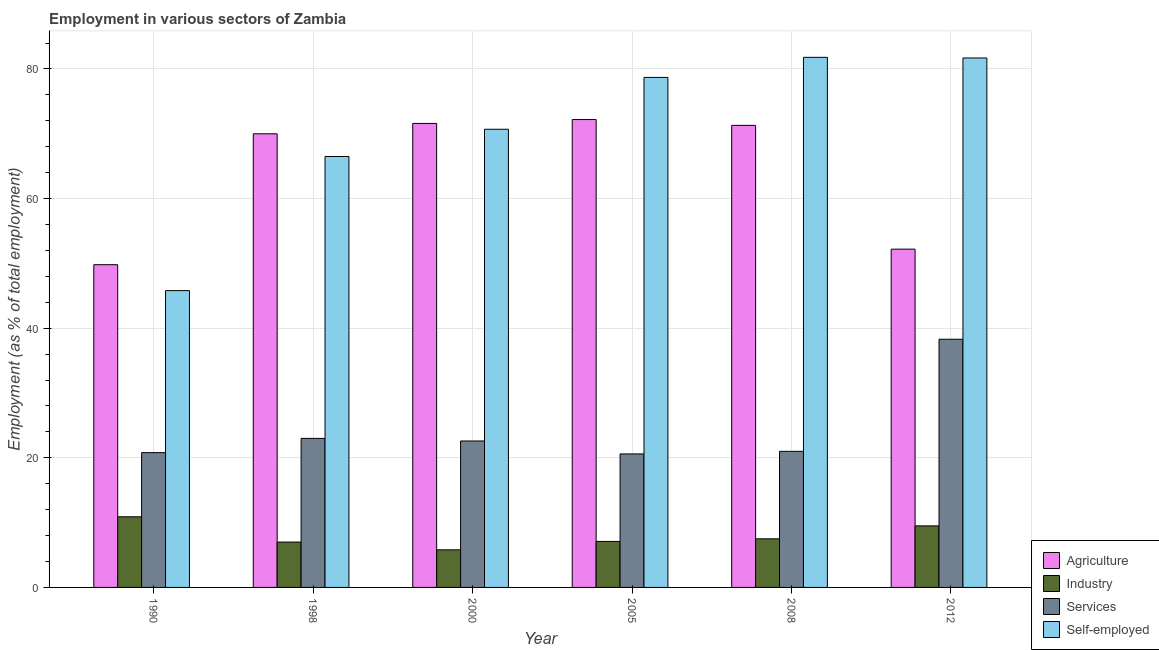How many groups of bars are there?
Make the answer very short. 6. How many bars are there on the 5th tick from the right?
Ensure brevity in your answer.  4. In how many cases, is the number of bars for a given year not equal to the number of legend labels?
Offer a terse response. 0. What is the percentage of self employed workers in 2008?
Give a very brief answer. 81.8. Across all years, what is the maximum percentage of workers in industry?
Your response must be concise. 10.9. Across all years, what is the minimum percentage of workers in services?
Give a very brief answer. 20.6. What is the total percentage of workers in services in the graph?
Your response must be concise. 146.3. What is the difference between the percentage of self employed workers in 1990 and that in 2005?
Provide a succinct answer. -32.9. What is the difference between the percentage of workers in industry in 1990 and the percentage of self employed workers in 2000?
Offer a terse response. 5.1. What is the average percentage of self employed workers per year?
Make the answer very short. 70.87. What is the ratio of the percentage of self employed workers in 1998 to that in 2012?
Keep it short and to the point. 0.81. Is the percentage of workers in agriculture in 2005 less than that in 2012?
Provide a short and direct response. No. What is the difference between the highest and the second highest percentage of workers in agriculture?
Make the answer very short. 0.6. What is the difference between the highest and the lowest percentage of self employed workers?
Give a very brief answer. 36. What does the 3rd bar from the left in 2005 represents?
Offer a very short reply. Services. What does the 1st bar from the right in 2012 represents?
Your response must be concise. Self-employed. Is it the case that in every year, the sum of the percentage of workers in agriculture and percentage of workers in industry is greater than the percentage of workers in services?
Keep it short and to the point. Yes. Are the values on the major ticks of Y-axis written in scientific E-notation?
Provide a short and direct response. No. Does the graph contain any zero values?
Offer a very short reply. No. Does the graph contain grids?
Keep it short and to the point. Yes. Where does the legend appear in the graph?
Offer a very short reply. Bottom right. How many legend labels are there?
Give a very brief answer. 4. What is the title of the graph?
Your answer should be compact. Employment in various sectors of Zambia. Does "Energy" appear as one of the legend labels in the graph?
Ensure brevity in your answer.  No. What is the label or title of the Y-axis?
Give a very brief answer. Employment (as % of total employment). What is the Employment (as % of total employment) of Agriculture in 1990?
Your answer should be very brief. 49.8. What is the Employment (as % of total employment) in Industry in 1990?
Offer a very short reply. 10.9. What is the Employment (as % of total employment) of Services in 1990?
Ensure brevity in your answer.  20.8. What is the Employment (as % of total employment) of Self-employed in 1990?
Your response must be concise. 45.8. What is the Employment (as % of total employment) in Agriculture in 1998?
Provide a short and direct response. 70. What is the Employment (as % of total employment) in Industry in 1998?
Provide a short and direct response. 7. What is the Employment (as % of total employment) of Services in 1998?
Your response must be concise. 23. What is the Employment (as % of total employment) of Self-employed in 1998?
Provide a succinct answer. 66.5. What is the Employment (as % of total employment) of Agriculture in 2000?
Provide a succinct answer. 71.6. What is the Employment (as % of total employment) in Industry in 2000?
Make the answer very short. 5.8. What is the Employment (as % of total employment) of Services in 2000?
Your answer should be compact. 22.6. What is the Employment (as % of total employment) in Self-employed in 2000?
Your answer should be very brief. 70.7. What is the Employment (as % of total employment) in Agriculture in 2005?
Ensure brevity in your answer.  72.2. What is the Employment (as % of total employment) in Industry in 2005?
Keep it short and to the point. 7.1. What is the Employment (as % of total employment) in Services in 2005?
Give a very brief answer. 20.6. What is the Employment (as % of total employment) in Self-employed in 2005?
Your response must be concise. 78.7. What is the Employment (as % of total employment) in Agriculture in 2008?
Provide a short and direct response. 71.3. What is the Employment (as % of total employment) of Services in 2008?
Give a very brief answer. 21. What is the Employment (as % of total employment) of Self-employed in 2008?
Offer a very short reply. 81.8. What is the Employment (as % of total employment) of Agriculture in 2012?
Provide a succinct answer. 52.2. What is the Employment (as % of total employment) of Services in 2012?
Offer a very short reply. 38.3. What is the Employment (as % of total employment) in Self-employed in 2012?
Provide a short and direct response. 81.7. Across all years, what is the maximum Employment (as % of total employment) of Agriculture?
Provide a short and direct response. 72.2. Across all years, what is the maximum Employment (as % of total employment) of Industry?
Your response must be concise. 10.9. Across all years, what is the maximum Employment (as % of total employment) of Services?
Provide a short and direct response. 38.3. Across all years, what is the maximum Employment (as % of total employment) of Self-employed?
Offer a terse response. 81.8. Across all years, what is the minimum Employment (as % of total employment) of Agriculture?
Offer a very short reply. 49.8. Across all years, what is the minimum Employment (as % of total employment) in Industry?
Keep it short and to the point. 5.8. Across all years, what is the minimum Employment (as % of total employment) of Services?
Give a very brief answer. 20.6. Across all years, what is the minimum Employment (as % of total employment) of Self-employed?
Keep it short and to the point. 45.8. What is the total Employment (as % of total employment) of Agriculture in the graph?
Offer a very short reply. 387.1. What is the total Employment (as % of total employment) in Industry in the graph?
Give a very brief answer. 47.8. What is the total Employment (as % of total employment) of Services in the graph?
Ensure brevity in your answer.  146.3. What is the total Employment (as % of total employment) in Self-employed in the graph?
Your answer should be very brief. 425.2. What is the difference between the Employment (as % of total employment) in Agriculture in 1990 and that in 1998?
Provide a succinct answer. -20.2. What is the difference between the Employment (as % of total employment) of Industry in 1990 and that in 1998?
Offer a terse response. 3.9. What is the difference between the Employment (as % of total employment) in Services in 1990 and that in 1998?
Provide a short and direct response. -2.2. What is the difference between the Employment (as % of total employment) in Self-employed in 1990 and that in 1998?
Give a very brief answer. -20.7. What is the difference between the Employment (as % of total employment) of Agriculture in 1990 and that in 2000?
Provide a short and direct response. -21.8. What is the difference between the Employment (as % of total employment) of Services in 1990 and that in 2000?
Offer a very short reply. -1.8. What is the difference between the Employment (as % of total employment) in Self-employed in 1990 and that in 2000?
Your answer should be very brief. -24.9. What is the difference between the Employment (as % of total employment) of Agriculture in 1990 and that in 2005?
Keep it short and to the point. -22.4. What is the difference between the Employment (as % of total employment) of Industry in 1990 and that in 2005?
Your response must be concise. 3.8. What is the difference between the Employment (as % of total employment) of Self-employed in 1990 and that in 2005?
Your answer should be compact. -32.9. What is the difference between the Employment (as % of total employment) in Agriculture in 1990 and that in 2008?
Provide a short and direct response. -21.5. What is the difference between the Employment (as % of total employment) of Services in 1990 and that in 2008?
Give a very brief answer. -0.2. What is the difference between the Employment (as % of total employment) of Self-employed in 1990 and that in 2008?
Keep it short and to the point. -36. What is the difference between the Employment (as % of total employment) of Agriculture in 1990 and that in 2012?
Your answer should be compact. -2.4. What is the difference between the Employment (as % of total employment) in Industry in 1990 and that in 2012?
Your answer should be compact. 1.4. What is the difference between the Employment (as % of total employment) in Services in 1990 and that in 2012?
Ensure brevity in your answer.  -17.5. What is the difference between the Employment (as % of total employment) of Self-employed in 1990 and that in 2012?
Ensure brevity in your answer.  -35.9. What is the difference between the Employment (as % of total employment) of Agriculture in 1998 and that in 2005?
Offer a terse response. -2.2. What is the difference between the Employment (as % of total employment) in Agriculture in 1998 and that in 2008?
Make the answer very short. -1.3. What is the difference between the Employment (as % of total employment) in Services in 1998 and that in 2008?
Keep it short and to the point. 2. What is the difference between the Employment (as % of total employment) in Self-employed in 1998 and that in 2008?
Your answer should be very brief. -15.3. What is the difference between the Employment (as % of total employment) in Agriculture in 1998 and that in 2012?
Keep it short and to the point. 17.8. What is the difference between the Employment (as % of total employment) in Services in 1998 and that in 2012?
Provide a succinct answer. -15.3. What is the difference between the Employment (as % of total employment) in Self-employed in 1998 and that in 2012?
Offer a very short reply. -15.2. What is the difference between the Employment (as % of total employment) of Agriculture in 2000 and that in 2005?
Give a very brief answer. -0.6. What is the difference between the Employment (as % of total employment) of Agriculture in 2000 and that in 2008?
Your response must be concise. 0.3. What is the difference between the Employment (as % of total employment) of Industry in 2000 and that in 2008?
Provide a short and direct response. -1.7. What is the difference between the Employment (as % of total employment) of Services in 2000 and that in 2008?
Offer a terse response. 1.6. What is the difference between the Employment (as % of total employment) of Self-employed in 2000 and that in 2008?
Provide a short and direct response. -11.1. What is the difference between the Employment (as % of total employment) in Agriculture in 2000 and that in 2012?
Keep it short and to the point. 19.4. What is the difference between the Employment (as % of total employment) in Industry in 2000 and that in 2012?
Ensure brevity in your answer.  -3.7. What is the difference between the Employment (as % of total employment) in Services in 2000 and that in 2012?
Provide a short and direct response. -15.7. What is the difference between the Employment (as % of total employment) in Agriculture in 2005 and that in 2008?
Make the answer very short. 0.9. What is the difference between the Employment (as % of total employment) in Services in 2005 and that in 2008?
Ensure brevity in your answer.  -0.4. What is the difference between the Employment (as % of total employment) in Self-employed in 2005 and that in 2008?
Your response must be concise. -3.1. What is the difference between the Employment (as % of total employment) in Agriculture in 2005 and that in 2012?
Your answer should be very brief. 20. What is the difference between the Employment (as % of total employment) in Services in 2005 and that in 2012?
Offer a very short reply. -17.7. What is the difference between the Employment (as % of total employment) in Agriculture in 2008 and that in 2012?
Ensure brevity in your answer.  19.1. What is the difference between the Employment (as % of total employment) in Industry in 2008 and that in 2012?
Your answer should be compact. -2. What is the difference between the Employment (as % of total employment) of Services in 2008 and that in 2012?
Your answer should be very brief. -17.3. What is the difference between the Employment (as % of total employment) in Self-employed in 2008 and that in 2012?
Make the answer very short. 0.1. What is the difference between the Employment (as % of total employment) of Agriculture in 1990 and the Employment (as % of total employment) of Industry in 1998?
Your answer should be compact. 42.8. What is the difference between the Employment (as % of total employment) in Agriculture in 1990 and the Employment (as % of total employment) in Services in 1998?
Your response must be concise. 26.8. What is the difference between the Employment (as % of total employment) in Agriculture in 1990 and the Employment (as % of total employment) in Self-employed in 1998?
Offer a very short reply. -16.7. What is the difference between the Employment (as % of total employment) in Industry in 1990 and the Employment (as % of total employment) in Services in 1998?
Offer a very short reply. -12.1. What is the difference between the Employment (as % of total employment) of Industry in 1990 and the Employment (as % of total employment) of Self-employed in 1998?
Make the answer very short. -55.6. What is the difference between the Employment (as % of total employment) in Services in 1990 and the Employment (as % of total employment) in Self-employed in 1998?
Offer a very short reply. -45.7. What is the difference between the Employment (as % of total employment) in Agriculture in 1990 and the Employment (as % of total employment) in Industry in 2000?
Your answer should be very brief. 44. What is the difference between the Employment (as % of total employment) in Agriculture in 1990 and the Employment (as % of total employment) in Services in 2000?
Provide a succinct answer. 27.2. What is the difference between the Employment (as % of total employment) in Agriculture in 1990 and the Employment (as % of total employment) in Self-employed in 2000?
Offer a terse response. -20.9. What is the difference between the Employment (as % of total employment) in Industry in 1990 and the Employment (as % of total employment) in Services in 2000?
Your answer should be very brief. -11.7. What is the difference between the Employment (as % of total employment) in Industry in 1990 and the Employment (as % of total employment) in Self-employed in 2000?
Your answer should be compact. -59.8. What is the difference between the Employment (as % of total employment) of Services in 1990 and the Employment (as % of total employment) of Self-employed in 2000?
Your answer should be compact. -49.9. What is the difference between the Employment (as % of total employment) of Agriculture in 1990 and the Employment (as % of total employment) of Industry in 2005?
Your answer should be compact. 42.7. What is the difference between the Employment (as % of total employment) in Agriculture in 1990 and the Employment (as % of total employment) in Services in 2005?
Your response must be concise. 29.2. What is the difference between the Employment (as % of total employment) in Agriculture in 1990 and the Employment (as % of total employment) in Self-employed in 2005?
Your response must be concise. -28.9. What is the difference between the Employment (as % of total employment) in Industry in 1990 and the Employment (as % of total employment) in Self-employed in 2005?
Your response must be concise. -67.8. What is the difference between the Employment (as % of total employment) of Services in 1990 and the Employment (as % of total employment) of Self-employed in 2005?
Offer a very short reply. -57.9. What is the difference between the Employment (as % of total employment) of Agriculture in 1990 and the Employment (as % of total employment) of Industry in 2008?
Your answer should be compact. 42.3. What is the difference between the Employment (as % of total employment) of Agriculture in 1990 and the Employment (as % of total employment) of Services in 2008?
Give a very brief answer. 28.8. What is the difference between the Employment (as % of total employment) in Agriculture in 1990 and the Employment (as % of total employment) in Self-employed in 2008?
Offer a terse response. -32. What is the difference between the Employment (as % of total employment) in Industry in 1990 and the Employment (as % of total employment) in Self-employed in 2008?
Keep it short and to the point. -70.9. What is the difference between the Employment (as % of total employment) of Services in 1990 and the Employment (as % of total employment) of Self-employed in 2008?
Provide a succinct answer. -61. What is the difference between the Employment (as % of total employment) in Agriculture in 1990 and the Employment (as % of total employment) in Industry in 2012?
Make the answer very short. 40.3. What is the difference between the Employment (as % of total employment) of Agriculture in 1990 and the Employment (as % of total employment) of Self-employed in 2012?
Provide a short and direct response. -31.9. What is the difference between the Employment (as % of total employment) of Industry in 1990 and the Employment (as % of total employment) of Services in 2012?
Give a very brief answer. -27.4. What is the difference between the Employment (as % of total employment) in Industry in 1990 and the Employment (as % of total employment) in Self-employed in 2012?
Your answer should be compact. -70.8. What is the difference between the Employment (as % of total employment) in Services in 1990 and the Employment (as % of total employment) in Self-employed in 2012?
Ensure brevity in your answer.  -60.9. What is the difference between the Employment (as % of total employment) in Agriculture in 1998 and the Employment (as % of total employment) in Industry in 2000?
Keep it short and to the point. 64.2. What is the difference between the Employment (as % of total employment) of Agriculture in 1998 and the Employment (as % of total employment) of Services in 2000?
Offer a very short reply. 47.4. What is the difference between the Employment (as % of total employment) in Industry in 1998 and the Employment (as % of total employment) in Services in 2000?
Keep it short and to the point. -15.6. What is the difference between the Employment (as % of total employment) of Industry in 1998 and the Employment (as % of total employment) of Self-employed in 2000?
Provide a succinct answer. -63.7. What is the difference between the Employment (as % of total employment) in Services in 1998 and the Employment (as % of total employment) in Self-employed in 2000?
Your response must be concise. -47.7. What is the difference between the Employment (as % of total employment) in Agriculture in 1998 and the Employment (as % of total employment) in Industry in 2005?
Offer a terse response. 62.9. What is the difference between the Employment (as % of total employment) of Agriculture in 1998 and the Employment (as % of total employment) of Services in 2005?
Make the answer very short. 49.4. What is the difference between the Employment (as % of total employment) of Industry in 1998 and the Employment (as % of total employment) of Self-employed in 2005?
Your answer should be compact. -71.7. What is the difference between the Employment (as % of total employment) of Services in 1998 and the Employment (as % of total employment) of Self-employed in 2005?
Provide a succinct answer. -55.7. What is the difference between the Employment (as % of total employment) of Agriculture in 1998 and the Employment (as % of total employment) of Industry in 2008?
Provide a succinct answer. 62.5. What is the difference between the Employment (as % of total employment) in Agriculture in 1998 and the Employment (as % of total employment) in Services in 2008?
Offer a very short reply. 49. What is the difference between the Employment (as % of total employment) in Agriculture in 1998 and the Employment (as % of total employment) in Self-employed in 2008?
Provide a short and direct response. -11.8. What is the difference between the Employment (as % of total employment) in Industry in 1998 and the Employment (as % of total employment) in Services in 2008?
Your response must be concise. -14. What is the difference between the Employment (as % of total employment) of Industry in 1998 and the Employment (as % of total employment) of Self-employed in 2008?
Provide a short and direct response. -74.8. What is the difference between the Employment (as % of total employment) in Services in 1998 and the Employment (as % of total employment) in Self-employed in 2008?
Provide a short and direct response. -58.8. What is the difference between the Employment (as % of total employment) in Agriculture in 1998 and the Employment (as % of total employment) in Industry in 2012?
Provide a short and direct response. 60.5. What is the difference between the Employment (as % of total employment) of Agriculture in 1998 and the Employment (as % of total employment) of Services in 2012?
Provide a succinct answer. 31.7. What is the difference between the Employment (as % of total employment) in Industry in 1998 and the Employment (as % of total employment) in Services in 2012?
Offer a terse response. -31.3. What is the difference between the Employment (as % of total employment) of Industry in 1998 and the Employment (as % of total employment) of Self-employed in 2012?
Your answer should be very brief. -74.7. What is the difference between the Employment (as % of total employment) of Services in 1998 and the Employment (as % of total employment) of Self-employed in 2012?
Give a very brief answer. -58.7. What is the difference between the Employment (as % of total employment) of Agriculture in 2000 and the Employment (as % of total employment) of Industry in 2005?
Your response must be concise. 64.5. What is the difference between the Employment (as % of total employment) in Agriculture in 2000 and the Employment (as % of total employment) in Services in 2005?
Ensure brevity in your answer.  51. What is the difference between the Employment (as % of total employment) in Industry in 2000 and the Employment (as % of total employment) in Services in 2005?
Provide a short and direct response. -14.8. What is the difference between the Employment (as % of total employment) of Industry in 2000 and the Employment (as % of total employment) of Self-employed in 2005?
Your response must be concise. -72.9. What is the difference between the Employment (as % of total employment) of Services in 2000 and the Employment (as % of total employment) of Self-employed in 2005?
Provide a succinct answer. -56.1. What is the difference between the Employment (as % of total employment) in Agriculture in 2000 and the Employment (as % of total employment) in Industry in 2008?
Your answer should be compact. 64.1. What is the difference between the Employment (as % of total employment) in Agriculture in 2000 and the Employment (as % of total employment) in Services in 2008?
Offer a very short reply. 50.6. What is the difference between the Employment (as % of total employment) in Agriculture in 2000 and the Employment (as % of total employment) in Self-employed in 2008?
Your answer should be very brief. -10.2. What is the difference between the Employment (as % of total employment) in Industry in 2000 and the Employment (as % of total employment) in Services in 2008?
Your answer should be very brief. -15.2. What is the difference between the Employment (as % of total employment) of Industry in 2000 and the Employment (as % of total employment) of Self-employed in 2008?
Make the answer very short. -76. What is the difference between the Employment (as % of total employment) of Services in 2000 and the Employment (as % of total employment) of Self-employed in 2008?
Offer a terse response. -59.2. What is the difference between the Employment (as % of total employment) in Agriculture in 2000 and the Employment (as % of total employment) in Industry in 2012?
Your answer should be very brief. 62.1. What is the difference between the Employment (as % of total employment) in Agriculture in 2000 and the Employment (as % of total employment) in Services in 2012?
Your answer should be compact. 33.3. What is the difference between the Employment (as % of total employment) of Agriculture in 2000 and the Employment (as % of total employment) of Self-employed in 2012?
Your answer should be very brief. -10.1. What is the difference between the Employment (as % of total employment) of Industry in 2000 and the Employment (as % of total employment) of Services in 2012?
Ensure brevity in your answer.  -32.5. What is the difference between the Employment (as % of total employment) in Industry in 2000 and the Employment (as % of total employment) in Self-employed in 2012?
Your response must be concise. -75.9. What is the difference between the Employment (as % of total employment) in Services in 2000 and the Employment (as % of total employment) in Self-employed in 2012?
Provide a succinct answer. -59.1. What is the difference between the Employment (as % of total employment) of Agriculture in 2005 and the Employment (as % of total employment) of Industry in 2008?
Give a very brief answer. 64.7. What is the difference between the Employment (as % of total employment) in Agriculture in 2005 and the Employment (as % of total employment) in Services in 2008?
Make the answer very short. 51.2. What is the difference between the Employment (as % of total employment) of Industry in 2005 and the Employment (as % of total employment) of Self-employed in 2008?
Provide a short and direct response. -74.7. What is the difference between the Employment (as % of total employment) in Services in 2005 and the Employment (as % of total employment) in Self-employed in 2008?
Offer a very short reply. -61.2. What is the difference between the Employment (as % of total employment) in Agriculture in 2005 and the Employment (as % of total employment) in Industry in 2012?
Offer a terse response. 62.7. What is the difference between the Employment (as % of total employment) of Agriculture in 2005 and the Employment (as % of total employment) of Services in 2012?
Your answer should be compact. 33.9. What is the difference between the Employment (as % of total employment) in Industry in 2005 and the Employment (as % of total employment) in Services in 2012?
Provide a succinct answer. -31.2. What is the difference between the Employment (as % of total employment) of Industry in 2005 and the Employment (as % of total employment) of Self-employed in 2012?
Give a very brief answer. -74.6. What is the difference between the Employment (as % of total employment) in Services in 2005 and the Employment (as % of total employment) in Self-employed in 2012?
Your answer should be very brief. -61.1. What is the difference between the Employment (as % of total employment) in Agriculture in 2008 and the Employment (as % of total employment) in Industry in 2012?
Your response must be concise. 61.8. What is the difference between the Employment (as % of total employment) in Agriculture in 2008 and the Employment (as % of total employment) in Services in 2012?
Your answer should be compact. 33. What is the difference between the Employment (as % of total employment) of Agriculture in 2008 and the Employment (as % of total employment) of Self-employed in 2012?
Provide a succinct answer. -10.4. What is the difference between the Employment (as % of total employment) of Industry in 2008 and the Employment (as % of total employment) of Services in 2012?
Ensure brevity in your answer.  -30.8. What is the difference between the Employment (as % of total employment) in Industry in 2008 and the Employment (as % of total employment) in Self-employed in 2012?
Give a very brief answer. -74.2. What is the difference between the Employment (as % of total employment) of Services in 2008 and the Employment (as % of total employment) of Self-employed in 2012?
Offer a very short reply. -60.7. What is the average Employment (as % of total employment) of Agriculture per year?
Your response must be concise. 64.52. What is the average Employment (as % of total employment) of Industry per year?
Your answer should be compact. 7.97. What is the average Employment (as % of total employment) in Services per year?
Make the answer very short. 24.38. What is the average Employment (as % of total employment) of Self-employed per year?
Provide a succinct answer. 70.87. In the year 1990, what is the difference between the Employment (as % of total employment) of Agriculture and Employment (as % of total employment) of Industry?
Offer a very short reply. 38.9. In the year 1990, what is the difference between the Employment (as % of total employment) of Agriculture and Employment (as % of total employment) of Self-employed?
Make the answer very short. 4. In the year 1990, what is the difference between the Employment (as % of total employment) of Industry and Employment (as % of total employment) of Self-employed?
Give a very brief answer. -34.9. In the year 1990, what is the difference between the Employment (as % of total employment) in Services and Employment (as % of total employment) in Self-employed?
Provide a short and direct response. -25. In the year 1998, what is the difference between the Employment (as % of total employment) in Agriculture and Employment (as % of total employment) in Services?
Offer a terse response. 47. In the year 1998, what is the difference between the Employment (as % of total employment) in Agriculture and Employment (as % of total employment) in Self-employed?
Keep it short and to the point. 3.5. In the year 1998, what is the difference between the Employment (as % of total employment) of Industry and Employment (as % of total employment) of Self-employed?
Offer a very short reply. -59.5. In the year 1998, what is the difference between the Employment (as % of total employment) in Services and Employment (as % of total employment) in Self-employed?
Offer a very short reply. -43.5. In the year 2000, what is the difference between the Employment (as % of total employment) of Agriculture and Employment (as % of total employment) of Industry?
Your answer should be compact. 65.8. In the year 2000, what is the difference between the Employment (as % of total employment) of Agriculture and Employment (as % of total employment) of Self-employed?
Offer a terse response. 0.9. In the year 2000, what is the difference between the Employment (as % of total employment) of Industry and Employment (as % of total employment) of Services?
Give a very brief answer. -16.8. In the year 2000, what is the difference between the Employment (as % of total employment) in Industry and Employment (as % of total employment) in Self-employed?
Give a very brief answer. -64.9. In the year 2000, what is the difference between the Employment (as % of total employment) in Services and Employment (as % of total employment) in Self-employed?
Provide a short and direct response. -48.1. In the year 2005, what is the difference between the Employment (as % of total employment) of Agriculture and Employment (as % of total employment) of Industry?
Your answer should be compact. 65.1. In the year 2005, what is the difference between the Employment (as % of total employment) in Agriculture and Employment (as % of total employment) in Services?
Give a very brief answer. 51.6. In the year 2005, what is the difference between the Employment (as % of total employment) of Industry and Employment (as % of total employment) of Self-employed?
Provide a succinct answer. -71.6. In the year 2005, what is the difference between the Employment (as % of total employment) of Services and Employment (as % of total employment) of Self-employed?
Your response must be concise. -58.1. In the year 2008, what is the difference between the Employment (as % of total employment) in Agriculture and Employment (as % of total employment) in Industry?
Give a very brief answer. 63.8. In the year 2008, what is the difference between the Employment (as % of total employment) in Agriculture and Employment (as % of total employment) in Services?
Your response must be concise. 50.3. In the year 2008, what is the difference between the Employment (as % of total employment) in Industry and Employment (as % of total employment) in Self-employed?
Give a very brief answer. -74.3. In the year 2008, what is the difference between the Employment (as % of total employment) of Services and Employment (as % of total employment) of Self-employed?
Make the answer very short. -60.8. In the year 2012, what is the difference between the Employment (as % of total employment) in Agriculture and Employment (as % of total employment) in Industry?
Your answer should be very brief. 42.7. In the year 2012, what is the difference between the Employment (as % of total employment) of Agriculture and Employment (as % of total employment) of Self-employed?
Your answer should be compact. -29.5. In the year 2012, what is the difference between the Employment (as % of total employment) of Industry and Employment (as % of total employment) of Services?
Keep it short and to the point. -28.8. In the year 2012, what is the difference between the Employment (as % of total employment) in Industry and Employment (as % of total employment) in Self-employed?
Provide a succinct answer. -72.2. In the year 2012, what is the difference between the Employment (as % of total employment) in Services and Employment (as % of total employment) in Self-employed?
Offer a very short reply. -43.4. What is the ratio of the Employment (as % of total employment) of Agriculture in 1990 to that in 1998?
Provide a short and direct response. 0.71. What is the ratio of the Employment (as % of total employment) in Industry in 1990 to that in 1998?
Offer a very short reply. 1.56. What is the ratio of the Employment (as % of total employment) in Services in 1990 to that in 1998?
Give a very brief answer. 0.9. What is the ratio of the Employment (as % of total employment) of Self-employed in 1990 to that in 1998?
Provide a succinct answer. 0.69. What is the ratio of the Employment (as % of total employment) of Agriculture in 1990 to that in 2000?
Provide a short and direct response. 0.7. What is the ratio of the Employment (as % of total employment) in Industry in 1990 to that in 2000?
Provide a succinct answer. 1.88. What is the ratio of the Employment (as % of total employment) of Services in 1990 to that in 2000?
Give a very brief answer. 0.92. What is the ratio of the Employment (as % of total employment) of Self-employed in 1990 to that in 2000?
Give a very brief answer. 0.65. What is the ratio of the Employment (as % of total employment) of Agriculture in 1990 to that in 2005?
Provide a short and direct response. 0.69. What is the ratio of the Employment (as % of total employment) of Industry in 1990 to that in 2005?
Ensure brevity in your answer.  1.54. What is the ratio of the Employment (as % of total employment) in Services in 1990 to that in 2005?
Give a very brief answer. 1.01. What is the ratio of the Employment (as % of total employment) in Self-employed in 1990 to that in 2005?
Keep it short and to the point. 0.58. What is the ratio of the Employment (as % of total employment) of Agriculture in 1990 to that in 2008?
Make the answer very short. 0.7. What is the ratio of the Employment (as % of total employment) of Industry in 1990 to that in 2008?
Your answer should be very brief. 1.45. What is the ratio of the Employment (as % of total employment) of Self-employed in 1990 to that in 2008?
Provide a succinct answer. 0.56. What is the ratio of the Employment (as % of total employment) of Agriculture in 1990 to that in 2012?
Provide a succinct answer. 0.95. What is the ratio of the Employment (as % of total employment) of Industry in 1990 to that in 2012?
Ensure brevity in your answer.  1.15. What is the ratio of the Employment (as % of total employment) of Services in 1990 to that in 2012?
Your response must be concise. 0.54. What is the ratio of the Employment (as % of total employment) of Self-employed in 1990 to that in 2012?
Keep it short and to the point. 0.56. What is the ratio of the Employment (as % of total employment) in Agriculture in 1998 to that in 2000?
Provide a short and direct response. 0.98. What is the ratio of the Employment (as % of total employment) of Industry in 1998 to that in 2000?
Offer a very short reply. 1.21. What is the ratio of the Employment (as % of total employment) in Services in 1998 to that in 2000?
Provide a short and direct response. 1.02. What is the ratio of the Employment (as % of total employment) of Self-employed in 1998 to that in 2000?
Keep it short and to the point. 0.94. What is the ratio of the Employment (as % of total employment) of Agriculture in 1998 to that in 2005?
Your answer should be very brief. 0.97. What is the ratio of the Employment (as % of total employment) of Industry in 1998 to that in 2005?
Provide a succinct answer. 0.99. What is the ratio of the Employment (as % of total employment) of Services in 1998 to that in 2005?
Your answer should be compact. 1.12. What is the ratio of the Employment (as % of total employment) in Self-employed in 1998 to that in 2005?
Make the answer very short. 0.84. What is the ratio of the Employment (as % of total employment) of Agriculture in 1998 to that in 2008?
Offer a terse response. 0.98. What is the ratio of the Employment (as % of total employment) in Industry in 1998 to that in 2008?
Give a very brief answer. 0.93. What is the ratio of the Employment (as % of total employment) in Services in 1998 to that in 2008?
Give a very brief answer. 1.1. What is the ratio of the Employment (as % of total employment) in Self-employed in 1998 to that in 2008?
Give a very brief answer. 0.81. What is the ratio of the Employment (as % of total employment) of Agriculture in 1998 to that in 2012?
Ensure brevity in your answer.  1.34. What is the ratio of the Employment (as % of total employment) in Industry in 1998 to that in 2012?
Offer a very short reply. 0.74. What is the ratio of the Employment (as % of total employment) in Services in 1998 to that in 2012?
Your answer should be very brief. 0.6. What is the ratio of the Employment (as % of total employment) in Self-employed in 1998 to that in 2012?
Your answer should be very brief. 0.81. What is the ratio of the Employment (as % of total employment) in Agriculture in 2000 to that in 2005?
Provide a short and direct response. 0.99. What is the ratio of the Employment (as % of total employment) in Industry in 2000 to that in 2005?
Offer a terse response. 0.82. What is the ratio of the Employment (as % of total employment) of Services in 2000 to that in 2005?
Provide a succinct answer. 1.1. What is the ratio of the Employment (as % of total employment) in Self-employed in 2000 to that in 2005?
Ensure brevity in your answer.  0.9. What is the ratio of the Employment (as % of total employment) of Agriculture in 2000 to that in 2008?
Your response must be concise. 1. What is the ratio of the Employment (as % of total employment) in Industry in 2000 to that in 2008?
Make the answer very short. 0.77. What is the ratio of the Employment (as % of total employment) of Services in 2000 to that in 2008?
Offer a terse response. 1.08. What is the ratio of the Employment (as % of total employment) of Self-employed in 2000 to that in 2008?
Provide a succinct answer. 0.86. What is the ratio of the Employment (as % of total employment) in Agriculture in 2000 to that in 2012?
Ensure brevity in your answer.  1.37. What is the ratio of the Employment (as % of total employment) in Industry in 2000 to that in 2012?
Provide a short and direct response. 0.61. What is the ratio of the Employment (as % of total employment) of Services in 2000 to that in 2012?
Provide a short and direct response. 0.59. What is the ratio of the Employment (as % of total employment) in Self-employed in 2000 to that in 2012?
Your response must be concise. 0.87. What is the ratio of the Employment (as % of total employment) in Agriculture in 2005 to that in 2008?
Your answer should be very brief. 1.01. What is the ratio of the Employment (as % of total employment) in Industry in 2005 to that in 2008?
Provide a succinct answer. 0.95. What is the ratio of the Employment (as % of total employment) of Services in 2005 to that in 2008?
Ensure brevity in your answer.  0.98. What is the ratio of the Employment (as % of total employment) in Self-employed in 2005 to that in 2008?
Your answer should be compact. 0.96. What is the ratio of the Employment (as % of total employment) in Agriculture in 2005 to that in 2012?
Ensure brevity in your answer.  1.38. What is the ratio of the Employment (as % of total employment) in Industry in 2005 to that in 2012?
Provide a short and direct response. 0.75. What is the ratio of the Employment (as % of total employment) in Services in 2005 to that in 2012?
Ensure brevity in your answer.  0.54. What is the ratio of the Employment (as % of total employment) in Self-employed in 2005 to that in 2012?
Make the answer very short. 0.96. What is the ratio of the Employment (as % of total employment) of Agriculture in 2008 to that in 2012?
Give a very brief answer. 1.37. What is the ratio of the Employment (as % of total employment) in Industry in 2008 to that in 2012?
Provide a succinct answer. 0.79. What is the ratio of the Employment (as % of total employment) of Services in 2008 to that in 2012?
Ensure brevity in your answer.  0.55. What is the ratio of the Employment (as % of total employment) of Self-employed in 2008 to that in 2012?
Give a very brief answer. 1. What is the difference between the highest and the second highest Employment (as % of total employment) in Industry?
Give a very brief answer. 1.4. What is the difference between the highest and the second highest Employment (as % of total employment) of Services?
Give a very brief answer. 15.3. What is the difference between the highest and the second highest Employment (as % of total employment) in Self-employed?
Ensure brevity in your answer.  0.1. What is the difference between the highest and the lowest Employment (as % of total employment) in Agriculture?
Your answer should be compact. 22.4. What is the difference between the highest and the lowest Employment (as % of total employment) in Industry?
Provide a succinct answer. 5.1. What is the difference between the highest and the lowest Employment (as % of total employment) in Self-employed?
Your response must be concise. 36. 